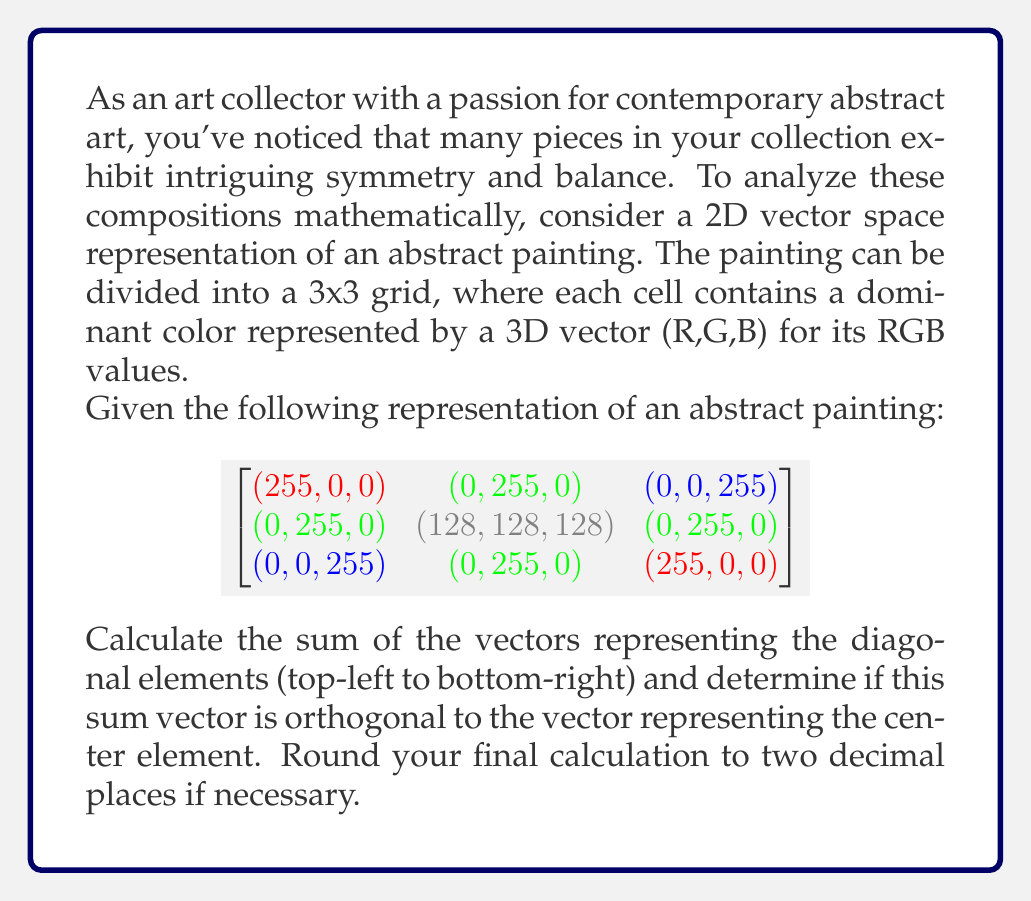Teach me how to tackle this problem. Let's approach this step-by-step:

1) First, we need to identify the diagonal elements and the center element:
   Diagonal elements: (255,0,0), (128,128,128), (255,0,0)
   Center element: (128,128,128)

2) Calculate the sum of the diagonal vectors:
   $$(255,0,0) + (128,128,128) + (255,0,0) = (638,128,128)$$

3) Let's call this sum vector $\vec{v} = (638,128,128)$ and the center vector $\vec{c} = (128,128,128)$

4) To check if these vectors are orthogonal, we need to calculate their dot product. If the dot product is zero, the vectors are orthogonal.

5) The dot product is calculated as:
   $$\vec{v} \cdot \vec{c} = 638 \times 128 + 128 \times 128 + 128 \times 128$$

6) Calculating:
   $$\vec{v} \cdot \vec{c} = 81664 + 16384 + 16384 = 114432$$

7) Since the dot product is not zero, the vectors are not orthogonal.

8) To quantify how far from orthogonal they are, we can calculate the cosine of the angle between them:
   
   $$\cos \theta = \frac{\vec{v} \cdot \vec{c}}{|\vec{v}| |\vec{c}|}$$

9) We need to calculate the magnitudes:
   $|\vec{v}| = \sqrt{638^2 + 128^2 + 128^2} = 667.25$
   $|\vec{c}| = \sqrt{128^2 + 128^2 + 128^2} = 221.70$

10) Now we can calculate $\cos \theta$:
    $$\cos \theta = \frac{114432}{667.25 \times 221.70} = 0.77$$

11) The angle between the vectors is:
    $$\theta = \arccos(0.77) = 0.69 \text{ radians} = 39.54\text{ degrees}$$
Answer: The vectors are not orthogonal; the angle between them is approximately 39.54°. 